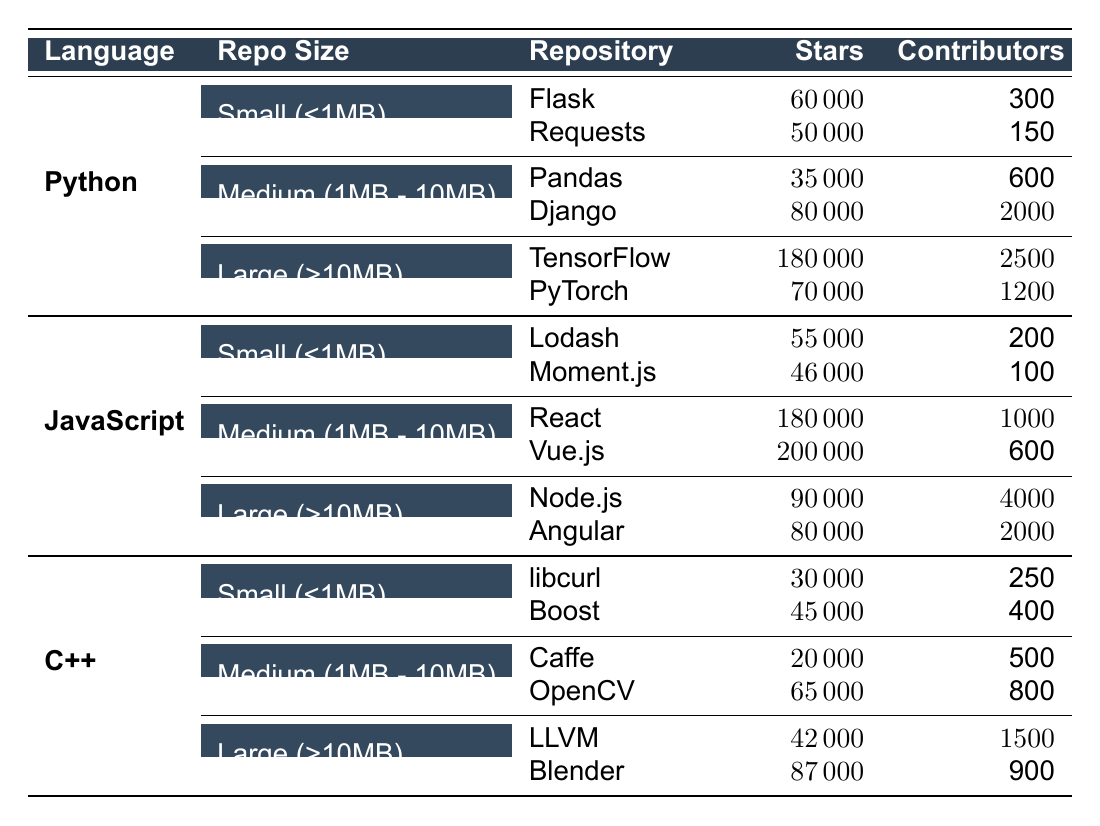What is the highest number of stars for a Python repository? In the Python section, I firstly look at the repositories under each size category: Small, Medium, and Large. The highest stars among the listed repositories is for TensorFlow under Large (>10MB), which has 180000 stars.
Answer: 180000 Which JavaScript repository has the fewest contributors? I check the JavaScript section for the number of contributors for each repository in all size categories. The repository with the least contributors is Moment.js, which has 100 contributors.
Answer: 100 Is there a repository in C++ with more contributors than the number of stars it has? I evaluate each repository in the C++ section: for libcurl, it has 30000 stars and 250 contributors; for Boost, 45000 stars and 400 contributors; for Caffe, 20000 stars and 500 contributors; for OpenCV, 65000 stars and 800 contributors; for LLVM, 42000 stars and 1500 contributors; and for Blender, 87000 stars and 900 contributors. None of the C++ repositories have more contributors than stars.
Answer: No What is the total number of contributors across all Python repositories? I sum the contributors for all Python repositories: 300 (Flask) + 150 (Requests) + 600 (Pandas) + 2000 (Django) + 2500 (TensorFlow) + 1200 (PyTorch) = 6000. Hence, the total number of contributors across all Python repositories is 6000.
Answer: 6000 Which language has the highest average number of stars per repository? To find the average stars for each language, I sum the stars for all repositories of that language and divide by the number of repositories: Python: (60000 + 50000 + 35000 + 80000 + 180000 + 70000) / 6 = 68500; JavaScript: (55000 + 46000 + 180000 + 200000 + 90000 + 80000) / 6 = 133333; C++: (30000 + 45000 + 20000 + 65000 + 42000 + 87000) / 6 = 50500. The highest average is for JavaScript at 133333 stars.
Answer: JavaScript Are there more small repositories in JavaScript or Python? In the table, I see that Python has 2 small repositories (Flask and Requests) and JavaScript also has 2 (Lodash and Moment.js). Therefore, the number of small repositories is equal.
Answer: Equal 